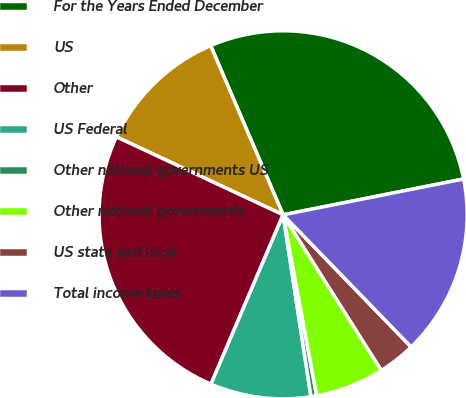<chart> <loc_0><loc_0><loc_500><loc_500><pie_chart><fcel>For the Years Ended December<fcel>US<fcel>Other<fcel>US Federal<fcel>Other national governments US<fcel>Other national governments<fcel>US state and local<fcel>Total income taxes<nl><fcel>28.32%<fcel>11.6%<fcel>25.55%<fcel>8.83%<fcel>0.5%<fcel>6.05%<fcel>3.28%<fcel>15.87%<nl></chart> 